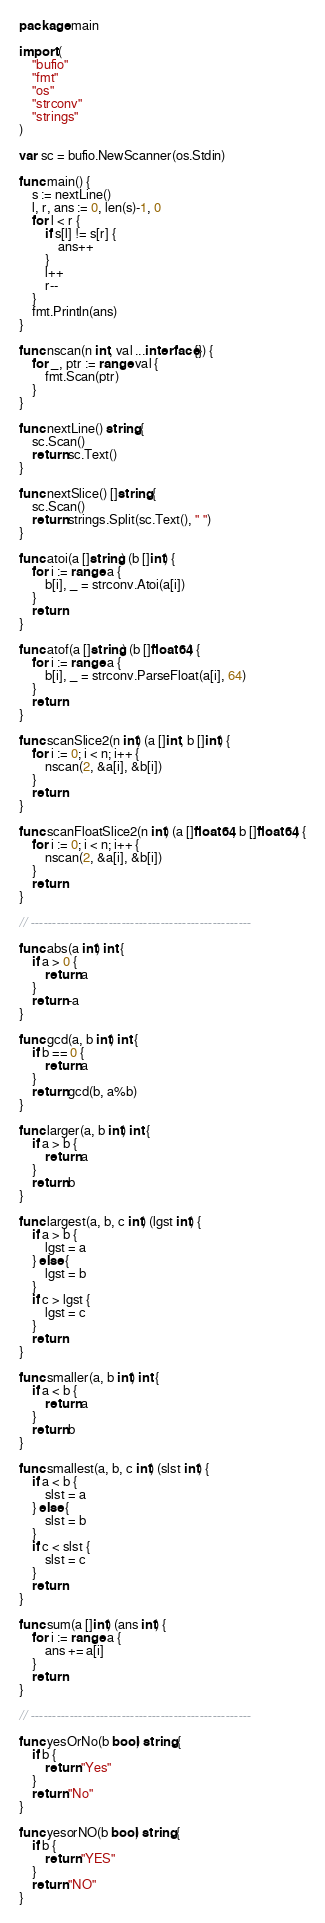<code> <loc_0><loc_0><loc_500><loc_500><_Go_>package main

import (
	"bufio"
	"fmt"
	"os"
	"strconv"
	"strings"
)

var sc = bufio.NewScanner(os.Stdin)

func main() {
	s := nextLine()
	l, r, ans := 0, len(s)-1, 0
	for l < r {
		if s[l] != s[r] {
			ans++
		}
		l++
		r--
	}
	fmt.Println(ans)
}

func nscan(n int, val ...interface{}) {
	for _, ptr := range val {
		fmt.Scan(ptr)
	}
}

func nextLine() string {
	sc.Scan()
	return sc.Text()
}

func nextSlice() []string {
	sc.Scan()
	return strings.Split(sc.Text(), " ")
}

func atoi(a []string) (b []int) {
	for i := range a {
		b[i], _ = strconv.Atoi(a[i])
	}
	return
}

func atof(a []string) (b []float64) {
	for i := range a {
		b[i], _ = strconv.ParseFloat(a[i], 64)
	}
	return
}

func scanSlice2(n int) (a []int, b []int) {
	for i := 0; i < n; i++ {
		nscan(2, &a[i], &b[i])
	}
	return
}

func scanFloatSlice2(n int) (a []float64, b []float64) {
	for i := 0; i < n; i++ {
		nscan(2, &a[i], &b[i])
	}
	return
}

// ---------------------------------------------------

func abs(a int) int {
	if a > 0 {
		return a
	}
	return -a
}

func gcd(a, b int) int {
	if b == 0 {
		return a
	}
	return gcd(b, a%b)
}

func larger(a, b int) int {
	if a > b {
		return a
	}
	return b
}

func largest(a, b, c int) (lgst int) {
	if a > b {
		lgst = a
	} else {
		lgst = b
	}
	if c > lgst {
		lgst = c
	}
	return
}

func smaller(a, b int) int {
	if a < b {
		return a
	}
	return b
}

func smallest(a, b, c int) (slst int) {
	if a < b {
		slst = a
	} else {
		slst = b
	}
	if c < slst {
		slst = c
	}
	return
}

func sum(a []int) (ans int) {
	for i := range a {
		ans += a[i]
	}
	return
}

// ---------------------------------------------------

func yesOrNo(b bool) string {
	if b {
		return "Yes"
	}
	return "No"
}

func yesorNO(b bool) string {
	if b {
		return "YES"
	}
	return "NO"
}</code> 